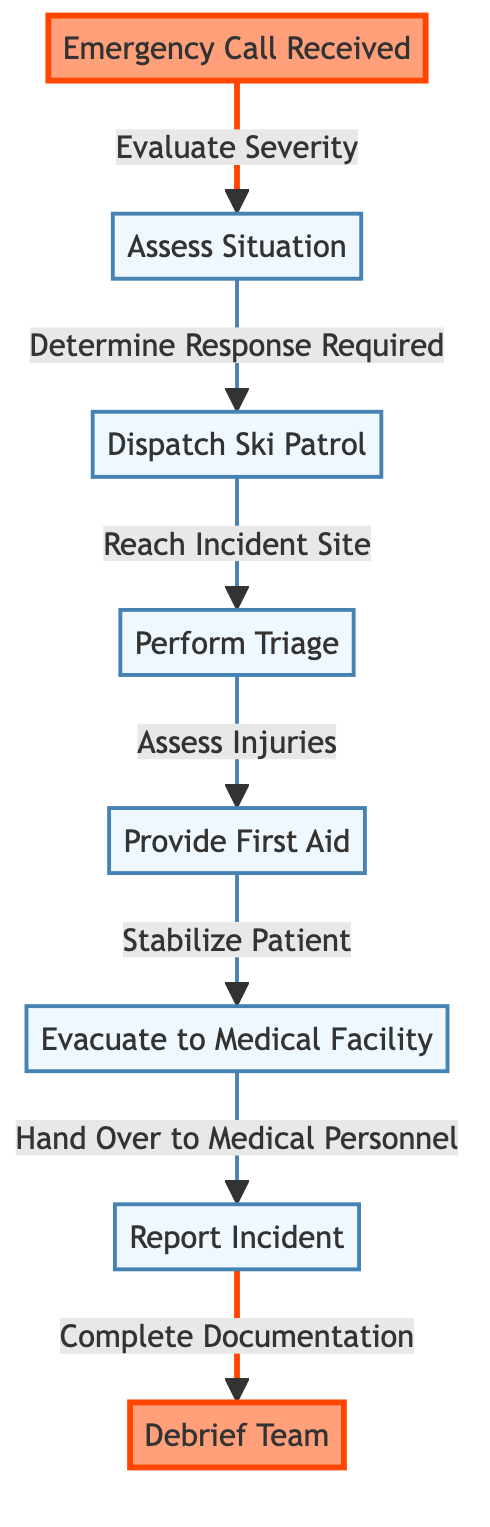What is the first step in the emergency response process? The first step is the "Emergency Call Received," which initiates the process flow for the ski patrol emergency response.
Answer: Emergency Call Received How many total nodes are in the diagram? By counting the individual boxes or steps in the flowchart, we find there are a total of 8 nodes representing various stages of the emergency response process.
Answer: 8 What action follows the "Assess Situation" step? After the "Assess Situation" step, the next action is to "Dispatch Ski Patrol," indicating the need to send a team to the site of the emergency.
Answer: Dispatch Ski Patrol Which step involves evaluating injuries? The step that involves evaluating injuries is "Perform Triage," where the ski patrol assesses the condition of those involved before providing aid.
Answer: Perform Triage What is the last action taken in the process flow? The last action in the process flow is "Debrief Team," which marks the completion of the emergency response and includes discussing the incident with the team.
Answer: Debrief Team If a situation is deemed severe, which step must be taken immediately after assessing it? If a situation is deemed severe after assessment, the immediate step to take is to "Dispatch Ski Patrol" to respond to the emergency.
Answer: Dispatch Ski Patrol In what step is patient stabilization prioritized? Patient stabilization occurs during the "Provide First Aid" step, where the ski patrol focuses on ensuring the patient's condition is secure before evacuation.
Answer: Provide First Aid How does the flowchart indicate the completion of documentation? Documentation is completed in the "Report Incident" step, following the handover to medical personnel and just before debriefing the team.
Answer: Report Incident 